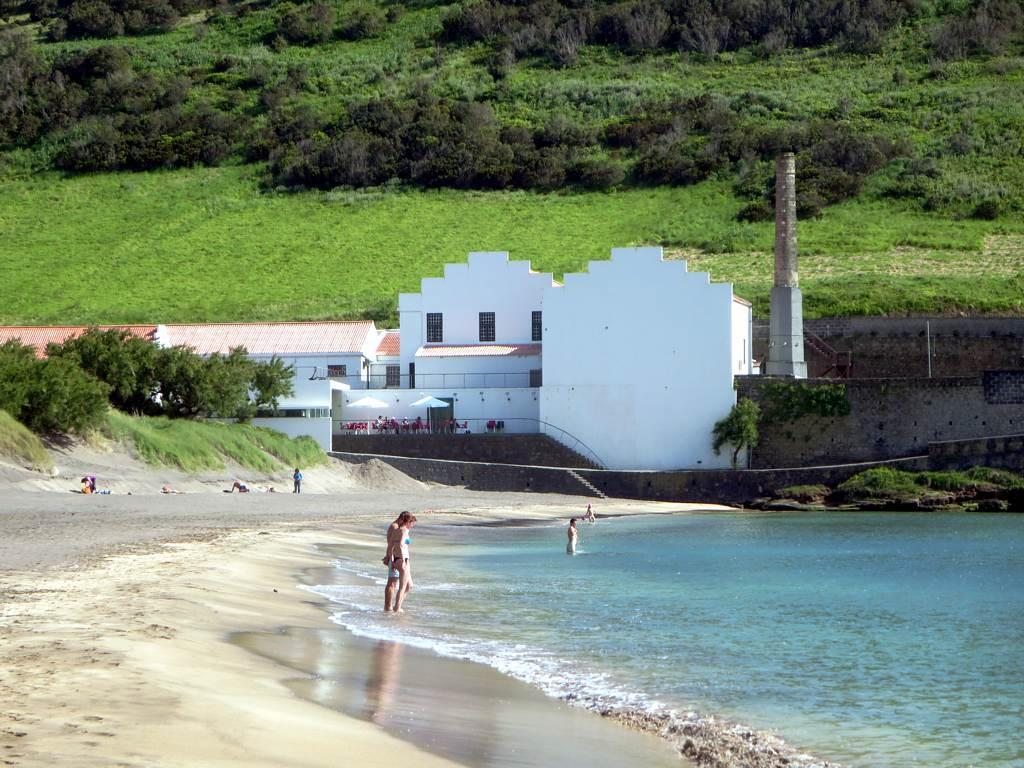How many people are in the image? There are people in the image, but the exact number is not specified. What type of natural elements can be seen in the image? There are trees and water visible in the image. What type of man-made structures are present in the image? There are buildings, windows, stairs, and a wall in the image. Are there any trees present in the image? Yes, there are trees in the image. What caption is written on the image? There is no caption present in the image. How many matches are visible in the image? There are no matches visible in the image. 